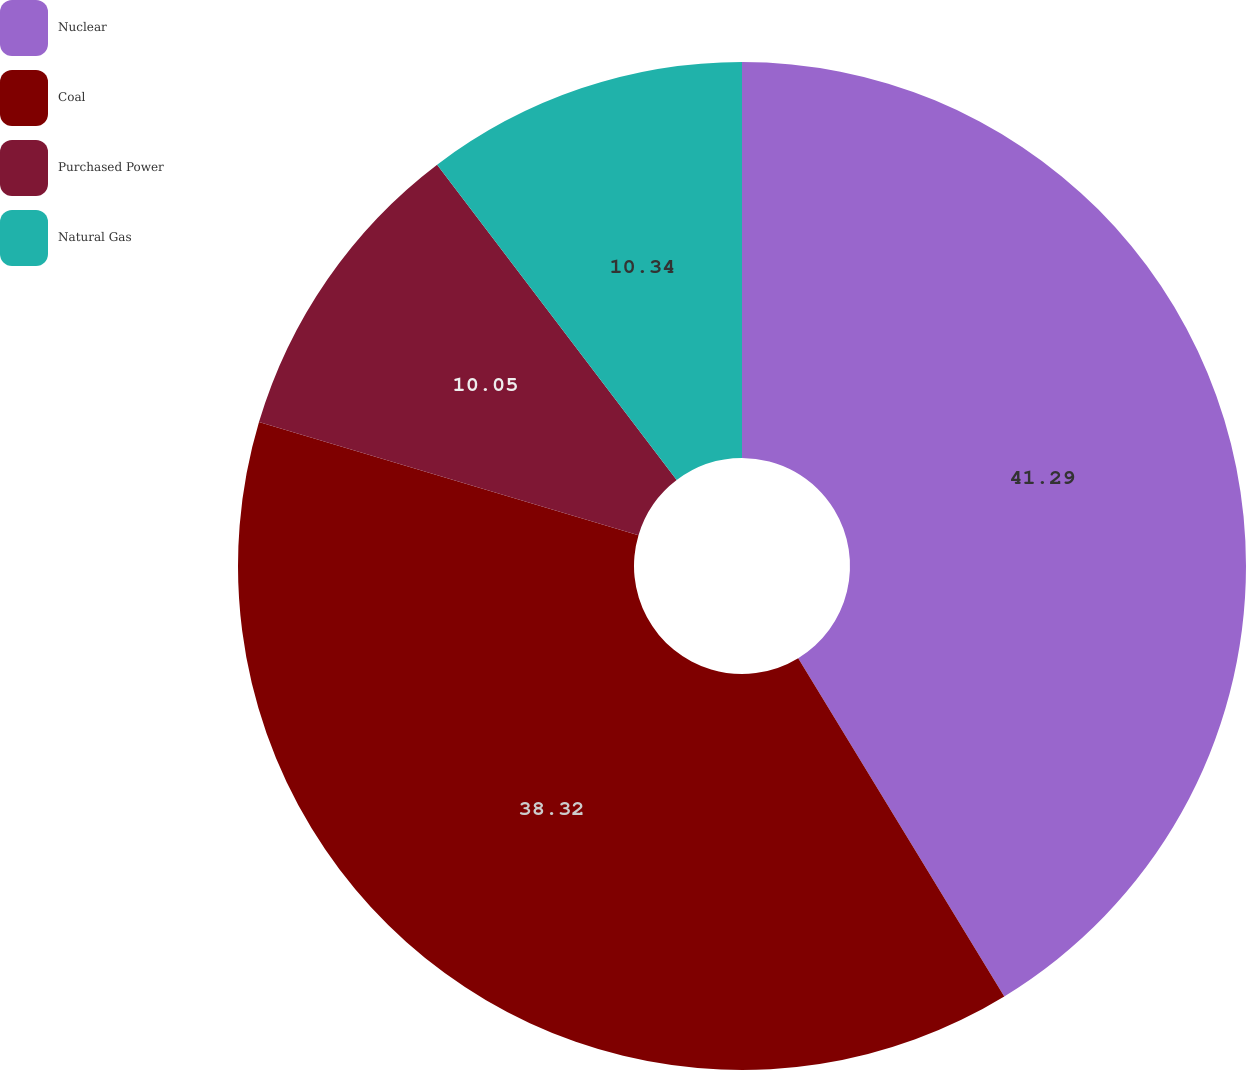Convert chart. <chart><loc_0><loc_0><loc_500><loc_500><pie_chart><fcel>Nuclear<fcel>Coal<fcel>Purchased Power<fcel>Natural Gas<nl><fcel>41.29%<fcel>38.32%<fcel>10.05%<fcel>10.34%<nl></chart> 